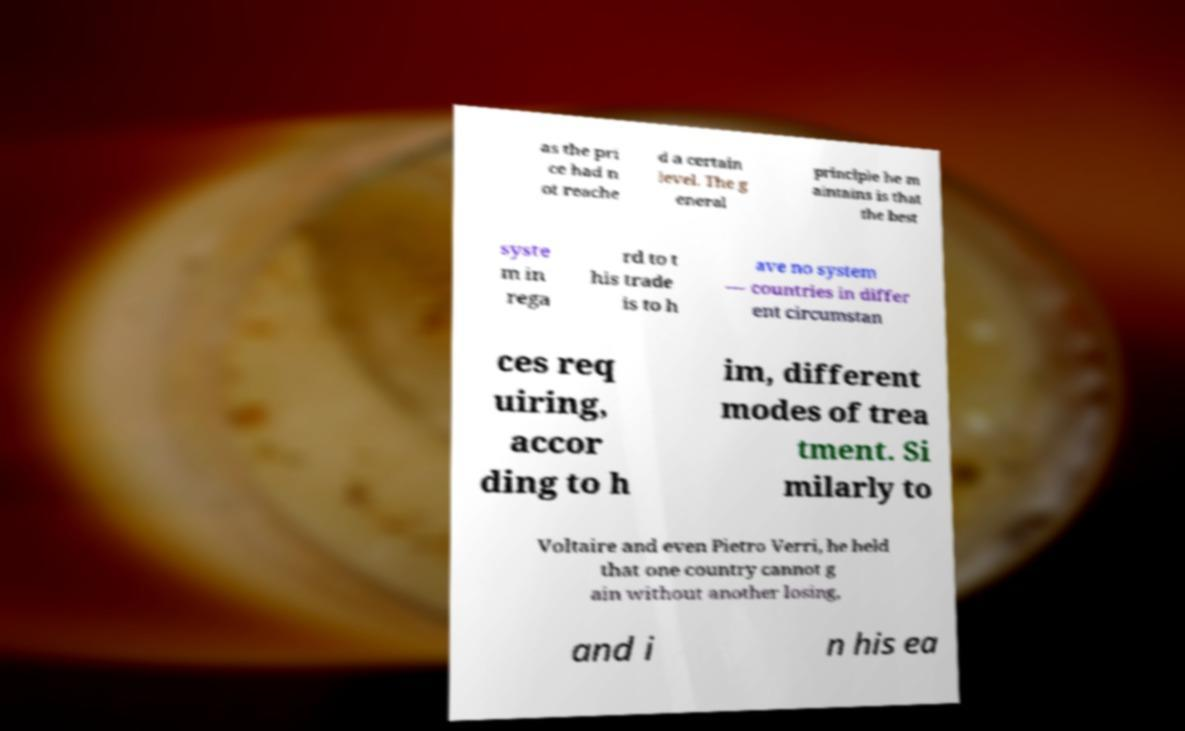I need the written content from this picture converted into text. Can you do that? as the pri ce had n ot reache d a certain level. The g eneral principle he m aintains is that the best syste m in rega rd to t his trade is to h ave no system — countries in differ ent circumstan ces req uiring, accor ding to h im, different modes of trea tment. Si milarly to Voltaire and even Pietro Verri, he held that one country cannot g ain without another losing, and i n his ea 